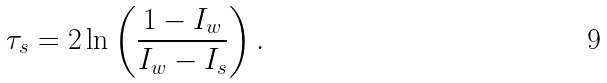Convert formula to latex. <formula><loc_0><loc_0><loc_500><loc_500>\tau _ { s } = 2 \ln \left ( \frac { 1 - I _ { w } } { I _ { w } - I _ { s } } \right ) .</formula> 